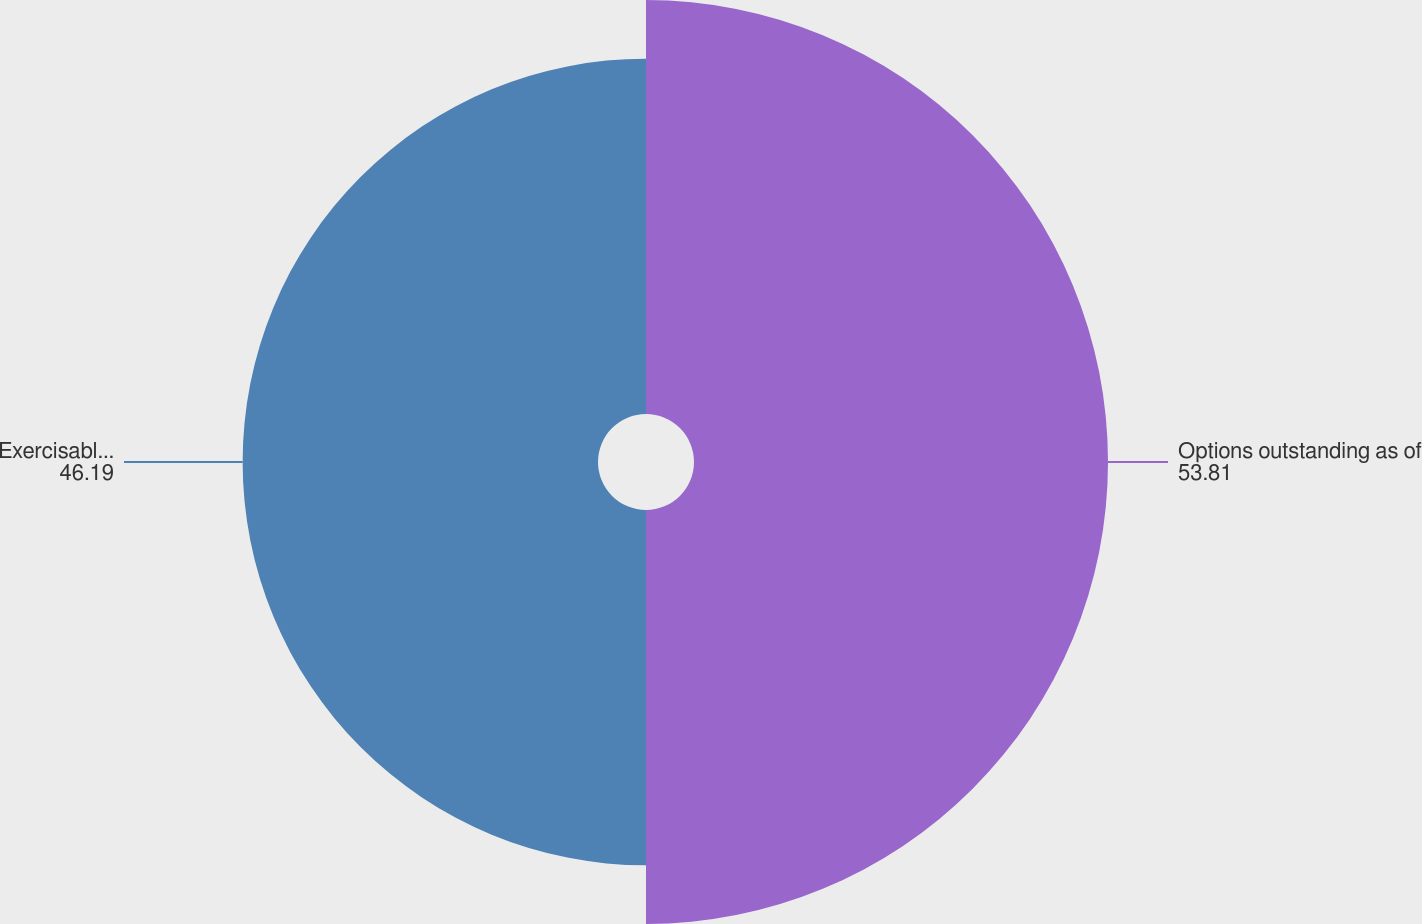Convert chart. <chart><loc_0><loc_0><loc_500><loc_500><pie_chart><fcel>Options outstanding as of<fcel>Exercisable as of December 31<nl><fcel>53.81%<fcel>46.19%<nl></chart> 